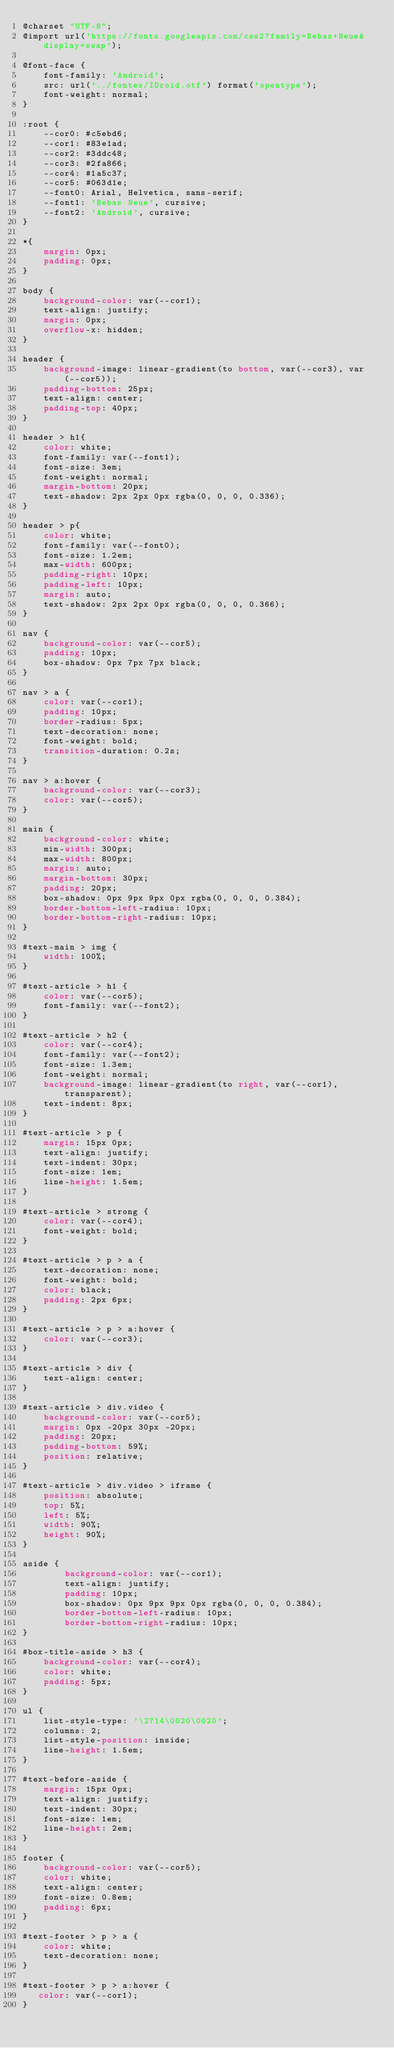<code> <loc_0><loc_0><loc_500><loc_500><_CSS_>@charset "UTF-8";
@import url('https://fonts.googleapis.com/css2?family=Bebas+Neue&display=swap');

@font-face {
    font-family: 'Android';
    src: url('../fontes/IDroid.otf') format('opentype');
    font-weight: normal;
}

:root {
    --cor0: #c5ebd6;
    --cor1: #83e1ad;
    --cor2: #3ddc48;
    --cor3: #2fa866;
    --cor4: #1a5c37;
    --cor5: #063d1e;
    --font0: Arial, Helvetica, sans-serif;
    --font1: 'Bebas Neue', cursive;
    --font2: 'Android', cursive;
}

*{
    margin: 0px;
    padding: 0px;
}

body {
    background-color: var(--cor1);
    text-align: justify;
    margin: 0px;
    overflow-x: hidden;
} 

header {
    background-image: linear-gradient(to bottom, var(--cor3), var(--cor5));
    padding-bottom: 25px;
    text-align: center;
    padding-top: 40px;
}

header > h1{
    color: white;
    font-family: var(--font1);
    font-size: 3em;
    font-weight: normal;
    margin-bottom: 20px;
    text-shadow: 2px 2px 0px rgba(0, 0, 0, 0.336);
}

header > p{
    color: white;
    font-family: var(--font0);
    font-size: 1.2em;
    max-width: 600px;
    padding-right: 10px;
    padding-left: 10px;
    margin: auto;
    text-shadow: 2px 2px 0px rgba(0, 0, 0, 0.366);
}

nav {
    background-color: var(--cor5);
    padding: 10px;
    box-shadow: 0px 7px 7px black;
}

nav > a {
    color: var(--cor1);
    padding: 10px;
    border-radius: 5px;
    text-decoration: none;
    font-weight: bold;
    transition-duration: 0.2s;
}

nav > a:hover {
    background-color: var(--cor3);
    color: var(--cor5);
}

main {
    background-color: white;
    min-width: 300px;
    max-width: 800px;
    margin: auto;
    margin-bottom: 30px;
    padding: 20px;
    box-shadow: 0px 9px 9px 0px rgba(0, 0, 0, 0.384);
    border-bottom-left-radius: 10px;
    border-bottom-right-radius: 10px;
}

#text-main > img {
    width: 100%;
}

#text-article > h1 {
    color: var(--cor5);
    font-family: var(--font2);
}

#text-article > h2 {
    color: var(--cor4);
    font-family: var(--font2);
    font-size: 1.3em;
    font-weight: normal;
    background-image: linear-gradient(to right, var(--cor1), transparent);
    text-indent: 8px; 
}

#text-article > p {
    margin: 15px 0px;
    text-align: justify;
    text-indent: 30px;
    font-size: 1em;
    line-height: 1.5em;
}

#text-article > strong {
    color: var(--cor4);
    font-weight: bold;
}

#text-article > p > a {
    text-decoration: none;
    font-weight: bold;
    color: black;
    padding: 2px 6px;
}

#text-article > p > a:hover {
    color: var(--cor3);
}

#text-article > div {
    text-align: center;
}

#text-article > div.video {
    background-color: var(--cor5);
    margin: 0px -20px 30px -20px;
    padding: 20px;
    padding-bottom: 59%;
    position: relative;
}

#text-article > div.video > iframe {
    position: absolute;
    top: 5%;
    left: 5%;
    width: 90%;
    height: 90%;
}

aside {
        background-color: var(--cor1);
        text-align: justify;
        padding: 10px;
        box-shadow: 0px 9px 9px 0px rgba(0, 0, 0, 0.384);
        border-bottom-left-radius: 10px;
        border-bottom-right-radius: 10px;
}

#box-title-aside > h3 {
    background-color: var(--cor4);
    color: white;
    padding: 5px;   
}

ul {
    list-style-type: '\2714\0020\0020';
    columns: 2;
    list-style-position: inside;
    line-height: 1.5em;
}

#text-before-aside {
    margin: 15px 0px;
    text-align: justify;
    text-indent: 30px;
    font-size: 1em;
    line-height: 2em;
}

footer {
    background-color: var(--cor5);
    color: white;
    text-align: center;
    font-size: 0.8em;
    padding: 6px;
}

#text-footer > p > a {
    color: white;
    text-decoration: none;
}

#text-footer > p > a:hover {
   color: var(--cor1);
}

</code> 